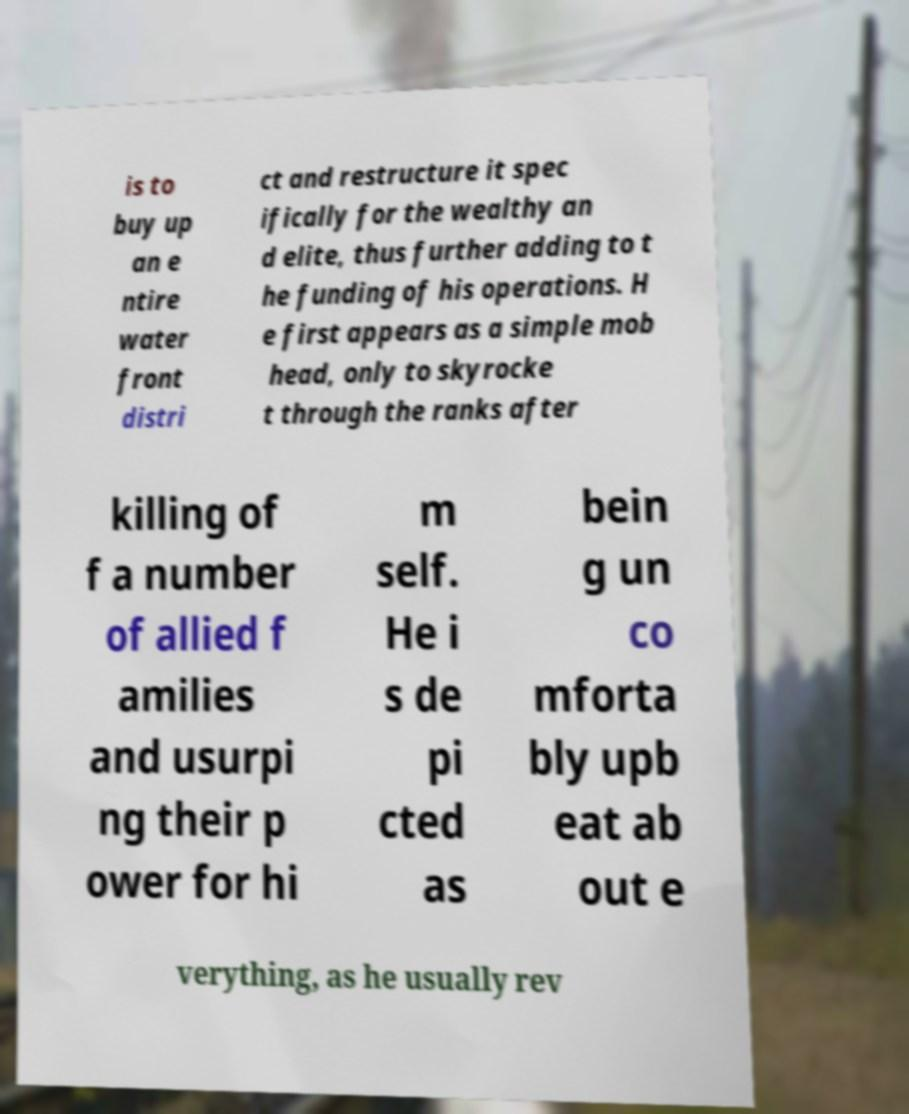Can you read and provide the text displayed in the image?This photo seems to have some interesting text. Can you extract and type it out for me? is to buy up an e ntire water front distri ct and restructure it spec ifically for the wealthy an d elite, thus further adding to t he funding of his operations. H e first appears as a simple mob head, only to skyrocke t through the ranks after killing of f a number of allied f amilies and usurpi ng their p ower for hi m self. He i s de pi cted as bein g un co mforta bly upb eat ab out e verything, as he usually rev 